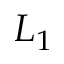Convert formula to latex. <formula><loc_0><loc_0><loc_500><loc_500>L _ { 1 }</formula> 